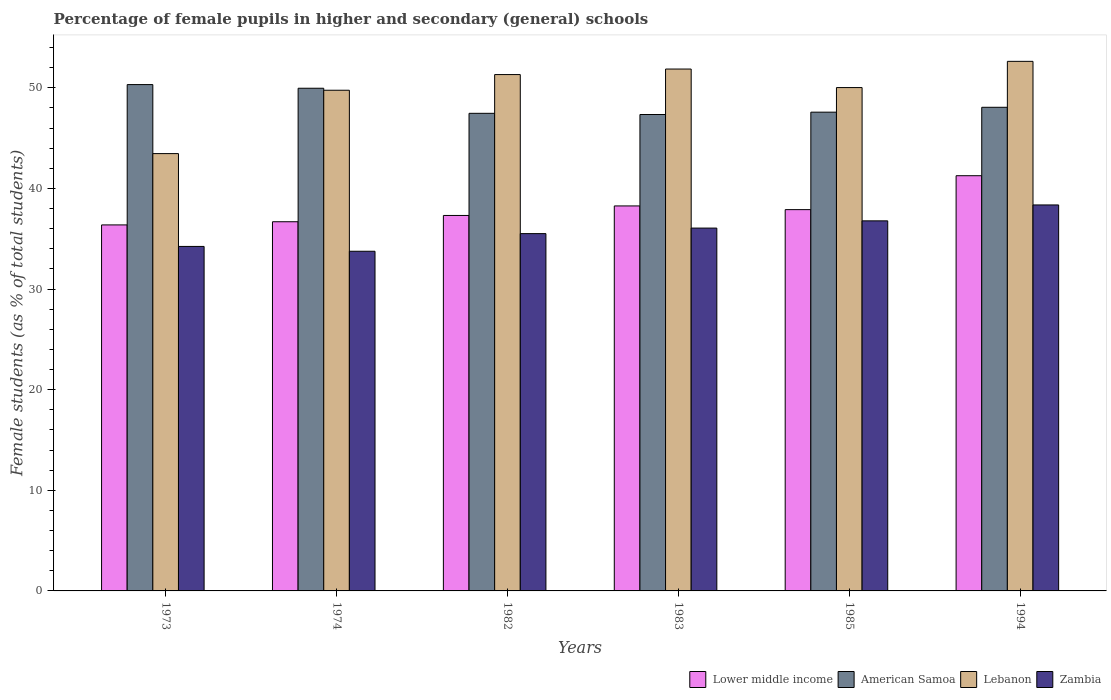How many different coloured bars are there?
Give a very brief answer. 4. Are the number of bars per tick equal to the number of legend labels?
Provide a succinct answer. Yes. Are the number of bars on each tick of the X-axis equal?
Offer a terse response. Yes. What is the label of the 2nd group of bars from the left?
Ensure brevity in your answer.  1974. In how many cases, is the number of bars for a given year not equal to the number of legend labels?
Offer a terse response. 0. What is the percentage of female pupils in higher and secondary schools in American Samoa in 1985?
Offer a terse response. 47.58. Across all years, what is the maximum percentage of female pupils in higher and secondary schools in American Samoa?
Your response must be concise. 50.32. Across all years, what is the minimum percentage of female pupils in higher and secondary schools in Zambia?
Offer a very short reply. 33.76. What is the total percentage of female pupils in higher and secondary schools in Zambia in the graph?
Offer a terse response. 214.71. What is the difference between the percentage of female pupils in higher and secondary schools in American Samoa in 1985 and that in 1994?
Make the answer very short. -0.48. What is the difference between the percentage of female pupils in higher and secondary schools in American Samoa in 1974 and the percentage of female pupils in higher and secondary schools in Zambia in 1985?
Provide a succinct answer. 13.18. What is the average percentage of female pupils in higher and secondary schools in American Samoa per year?
Ensure brevity in your answer.  48.46. In the year 1973, what is the difference between the percentage of female pupils in higher and secondary schools in Lebanon and percentage of female pupils in higher and secondary schools in Zambia?
Provide a succinct answer. 9.23. What is the ratio of the percentage of female pupils in higher and secondary schools in Lower middle income in 1982 to that in 1994?
Provide a succinct answer. 0.9. Is the difference between the percentage of female pupils in higher and secondary schools in Lebanon in 1974 and 1994 greater than the difference between the percentage of female pupils in higher and secondary schools in Zambia in 1974 and 1994?
Your response must be concise. Yes. What is the difference between the highest and the second highest percentage of female pupils in higher and secondary schools in Lower middle income?
Your answer should be compact. 3. What is the difference between the highest and the lowest percentage of female pupils in higher and secondary schools in Lower middle income?
Your answer should be very brief. 4.89. Is the sum of the percentage of female pupils in higher and secondary schools in Lower middle income in 1973 and 1983 greater than the maximum percentage of female pupils in higher and secondary schools in American Samoa across all years?
Provide a short and direct response. Yes. Is it the case that in every year, the sum of the percentage of female pupils in higher and secondary schools in Lebanon and percentage of female pupils in higher and secondary schools in Lower middle income is greater than the sum of percentage of female pupils in higher and secondary schools in Zambia and percentage of female pupils in higher and secondary schools in American Samoa?
Your response must be concise. Yes. What does the 3rd bar from the left in 1974 represents?
Your answer should be compact. Lebanon. What does the 1st bar from the right in 1973 represents?
Give a very brief answer. Zambia. How many bars are there?
Your response must be concise. 24. How many years are there in the graph?
Offer a very short reply. 6. Does the graph contain any zero values?
Your answer should be compact. No. Where does the legend appear in the graph?
Offer a terse response. Bottom right. What is the title of the graph?
Ensure brevity in your answer.  Percentage of female pupils in higher and secondary (general) schools. What is the label or title of the X-axis?
Provide a short and direct response. Years. What is the label or title of the Y-axis?
Provide a succinct answer. Female students (as % of total students). What is the Female students (as % of total students) in Lower middle income in 1973?
Provide a succinct answer. 36.38. What is the Female students (as % of total students) of American Samoa in 1973?
Your response must be concise. 50.32. What is the Female students (as % of total students) in Lebanon in 1973?
Give a very brief answer. 43.46. What is the Female students (as % of total students) of Zambia in 1973?
Make the answer very short. 34.24. What is the Female students (as % of total students) in Lower middle income in 1974?
Your answer should be very brief. 36.69. What is the Female students (as % of total students) in American Samoa in 1974?
Your response must be concise. 49.96. What is the Female students (as % of total students) in Lebanon in 1974?
Keep it short and to the point. 49.76. What is the Female students (as % of total students) in Zambia in 1974?
Make the answer very short. 33.76. What is the Female students (as % of total students) of Lower middle income in 1982?
Your answer should be very brief. 37.31. What is the Female students (as % of total students) of American Samoa in 1982?
Your answer should be very brief. 47.47. What is the Female students (as % of total students) of Lebanon in 1982?
Give a very brief answer. 51.32. What is the Female students (as % of total students) in Zambia in 1982?
Offer a terse response. 35.51. What is the Female students (as % of total students) of Lower middle income in 1983?
Give a very brief answer. 38.26. What is the Female students (as % of total students) in American Samoa in 1983?
Keep it short and to the point. 47.35. What is the Female students (as % of total students) in Lebanon in 1983?
Make the answer very short. 51.87. What is the Female students (as % of total students) in Zambia in 1983?
Your answer should be very brief. 36.06. What is the Female students (as % of total students) in Lower middle income in 1985?
Your answer should be very brief. 37.89. What is the Female students (as % of total students) of American Samoa in 1985?
Keep it short and to the point. 47.58. What is the Female students (as % of total students) of Lebanon in 1985?
Make the answer very short. 50.03. What is the Female students (as % of total students) of Zambia in 1985?
Your answer should be compact. 36.78. What is the Female students (as % of total students) of Lower middle income in 1994?
Offer a very short reply. 41.27. What is the Female students (as % of total students) in American Samoa in 1994?
Offer a terse response. 48.07. What is the Female students (as % of total students) of Lebanon in 1994?
Provide a succinct answer. 52.63. What is the Female students (as % of total students) of Zambia in 1994?
Make the answer very short. 38.36. Across all years, what is the maximum Female students (as % of total students) in Lower middle income?
Offer a very short reply. 41.27. Across all years, what is the maximum Female students (as % of total students) of American Samoa?
Provide a succinct answer. 50.32. Across all years, what is the maximum Female students (as % of total students) in Lebanon?
Offer a terse response. 52.63. Across all years, what is the maximum Female students (as % of total students) in Zambia?
Your answer should be compact. 38.36. Across all years, what is the minimum Female students (as % of total students) in Lower middle income?
Your answer should be very brief. 36.38. Across all years, what is the minimum Female students (as % of total students) of American Samoa?
Provide a short and direct response. 47.35. Across all years, what is the minimum Female students (as % of total students) of Lebanon?
Make the answer very short. 43.46. Across all years, what is the minimum Female students (as % of total students) of Zambia?
Your answer should be compact. 33.76. What is the total Female students (as % of total students) in Lower middle income in the graph?
Ensure brevity in your answer.  227.8. What is the total Female students (as % of total students) in American Samoa in the graph?
Ensure brevity in your answer.  290.74. What is the total Female students (as % of total students) in Lebanon in the graph?
Offer a terse response. 299.06. What is the total Female students (as % of total students) of Zambia in the graph?
Give a very brief answer. 214.71. What is the difference between the Female students (as % of total students) of Lower middle income in 1973 and that in 1974?
Offer a terse response. -0.31. What is the difference between the Female students (as % of total students) in American Samoa in 1973 and that in 1974?
Give a very brief answer. 0.36. What is the difference between the Female students (as % of total students) in Lebanon in 1973 and that in 1974?
Offer a terse response. -6.3. What is the difference between the Female students (as % of total students) of Zambia in 1973 and that in 1974?
Offer a very short reply. 0.48. What is the difference between the Female students (as % of total students) of Lower middle income in 1973 and that in 1982?
Your response must be concise. -0.94. What is the difference between the Female students (as % of total students) in American Samoa in 1973 and that in 1982?
Give a very brief answer. 2.86. What is the difference between the Female students (as % of total students) in Lebanon in 1973 and that in 1982?
Your answer should be very brief. -7.85. What is the difference between the Female students (as % of total students) of Zambia in 1973 and that in 1982?
Keep it short and to the point. -1.27. What is the difference between the Female students (as % of total students) of Lower middle income in 1973 and that in 1983?
Ensure brevity in your answer.  -1.89. What is the difference between the Female students (as % of total students) in American Samoa in 1973 and that in 1983?
Your answer should be compact. 2.97. What is the difference between the Female students (as % of total students) of Lebanon in 1973 and that in 1983?
Keep it short and to the point. -8.4. What is the difference between the Female students (as % of total students) in Zambia in 1973 and that in 1983?
Keep it short and to the point. -1.82. What is the difference between the Female students (as % of total students) in Lower middle income in 1973 and that in 1985?
Provide a succinct answer. -1.52. What is the difference between the Female students (as % of total students) in American Samoa in 1973 and that in 1985?
Make the answer very short. 2.74. What is the difference between the Female students (as % of total students) of Lebanon in 1973 and that in 1985?
Make the answer very short. -6.56. What is the difference between the Female students (as % of total students) in Zambia in 1973 and that in 1985?
Provide a succinct answer. -2.54. What is the difference between the Female students (as % of total students) of Lower middle income in 1973 and that in 1994?
Offer a terse response. -4.89. What is the difference between the Female students (as % of total students) in American Samoa in 1973 and that in 1994?
Keep it short and to the point. 2.26. What is the difference between the Female students (as % of total students) of Lebanon in 1973 and that in 1994?
Give a very brief answer. -9.17. What is the difference between the Female students (as % of total students) of Zambia in 1973 and that in 1994?
Provide a succinct answer. -4.12. What is the difference between the Female students (as % of total students) of Lower middle income in 1974 and that in 1982?
Make the answer very short. -0.62. What is the difference between the Female students (as % of total students) in American Samoa in 1974 and that in 1982?
Your answer should be compact. 2.49. What is the difference between the Female students (as % of total students) in Lebanon in 1974 and that in 1982?
Your response must be concise. -1.56. What is the difference between the Female students (as % of total students) of Zambia in 1974 and that in 1982?
Offer a terse response. -1.75. What is the difference between the Female students (as % of total students) in Lower middle income in 1974 and that in 1983?
Ensure brevity in your answer.  -1.57. What is the difference between the Female students (as % of total students) of American Samoa in 1974 and that in 1983?
Offer a terse response. 2.61. What is the difference between the Female students (as % of total students) of Lebanon in 1974 and that in 1983?
Give a very brief answer. -2.11. What is the difference between the Female students (as % of total students) in Zambia in 1974 and that in 1983?
Offer a very short reply. -2.3. What is the difference between the Female students (as % of total students) of Lower middle income in 1974 and that in 1985?
Your response must be concise. -1.2. What is the difference between the Female students (as % of total students) in American Samoa in 1974 and that in 1985?
Make the answer very short. 2.38. What is the difference between the Female students (as % of total students) in Lebanon in 1974 and that in 1985?
Ensure brevity in your answer.  -0.26. What is the difference between the Female students (as % of total students) of Zambia in 1974 and that in 1985?
Offer a terse response. -3.02. What is the difference between the Female students (as % of total students) in Lower middle income in 1974 and that in 1994?
Provide a short and direct response. -4.58. What is the difference between the Female students (as % of total students) of American Samoa in 1974 and that in 1994?
Make the answer very short. 1.89. What is the difference between the Female students (as % of total students) in Lebanon in 1974 and that in 1994?
Make the answer very short. -2.87. What is the difference between the Female students (as % of total students) in Zambia in 1974 and that in 1994?
Keep it short and to the point. -4.6. What is the difference between the Female students (as % of total students) of Lower middle income in 1982 and that in 1983?
Offer a terse response. -0.95. What is the difference between the Female students (as % of total students) of American Samoa in 1982 and that in 1983?
Provide a short and direct response. 0.12. What is the difference between the Female students (as % of total students) of Lebanon in 1982 and that in 1983?
Offer a terse response. -0.55. What is the difference between the Female students (as % of total students) of Zambia in 1982 and that in 1983?
Provide a short and direct response. -0.55. What is the difference between the Female students (as % of total students) of Lower middle income in 1982 and that in 1985?
Ensure brevity in your answer.  -0.58. What is the difference between the Female students (as % of total students) in American Samoa in 1982 and that in 1985?
Provide a succinct answer. -0.12. What is the difference between the Female students (as % of total students) of Lebanon in 1982 and that in 1985?
Provide a succinct answer. 1.29. What is the difference between the Female students (as % of total students) in Zambia in 1982 and that in 1985?
Make the answer very short. -1.27. What is the difference between the Female students (as % of total students) in Lower middle income in 1982 and that in 1994?
Offer a terse response. -3.95. What is the difference between the Female students (as % of total students) in American Samoa in 1982 and that in 1994?
Provide a succinct answer. -0.6. What is the difference between the Female students (as % of total students) in Lebanon in 1982 and that in 1994?
Offer a terse response. -1.31. What is the difference between the Female students (as % of total students) in Zambia in 1982 and that in 1994?
Your answer should be compact. -2.85. What is the difference between the Female students (as % of total students) of Lower middle income in 1983 and that in 1985?
Your response must be concise. 0.37. What is the difference between the Female students (as % of total students) of American Samoa in 1983 and that in 1985?
Give a very brief answer. -0.23. What is the difference between the Female students (as % of total students) in Lebanon in 1983 and that in 1985?
Your answer should be compact. 1.84. What is the difference between the Female students (as % of total students) of Zambia in 1983 and that in 1985?
Provide a short and direct response. -0.72. What is the difference between the Female students (as % of total students) of Lower middle income in 1983 and that in 1994?
Your answer should be very brief. -3. What is the difference between the Female students (as % of total students) in American Samoa in 1983 and that in 1994?
Provide a succinct answer. -0.72. What is the difference between the Female students (as % of total students) in Lebanon in 1983 and that in 1994?
Provide a succinct answer. -0.76. What is the difference between the Female students (as % of total students) in Zambia in 1983 and that in 1994?
Make the answer very short. -2.3. What is the difference between the Female students (as % of total students) of Lower middle income in 1985 and that in 1994?
Provide a succinct answer. -3.37. What is the difference between the Female students (as % of total students) in American Samoa in 1985 and that in 1994?
Make the answer very short. -0.48. What is the difference between the Female students (as % of total students) of Lebanon in 1985 and that in 1994?
Keep it short and to the point. -2.61. What is the difference between the Female students (as % of total students) of Zambia in 1985 and that in 1994?
Your answer should be very brief. -1.58. What is the difference between the Female students (as % of total students) in Lower middle income in 1973 and the Female students (as % of total students) in American Samoa in 1974?
Ensure brevity in your answer.  -13.58. What is the difference between the Female students (as % of total students) of Lower middle income in 1973 and the Female students (as % of total students) of Lebanon in 1974?
Give a very brief answer. -13.38. What is the difference between the Female students (as % of total students) in Lower middle income in 1973 and the Female students (as % of total students) in Zambia in 1974?
Offer a very short reply. 2.62. What is the difference between the Female students (as % of total students) of American Samoa in 1973 and the Female students (as % of total students) of Lebanon in 1974?
Offer a very short reply. 0.56. What is the difference between the Female students (as % of total students) of American Samoa in 1973 and the Female students (as % of total students) of Zambia in 1974?
Make the answer very short. 16.57. What is the difference between the Female students (as % of total students) in Lebanon in 1973 and the Female students (as % of total students) in Zambia in 1974?
Offer a very short reply. 9.71. What is the difference between the Female students (as % of total students) in Lower middle income in 1973 and the Female students (as % of total students) in American Samoa in 1982?
Your response must be concise. -11.09. What is the difference between the Female students (as % of total students) of Lower middle income in 1973 and the Female students (as % of total students) of Lebanon in 1982?
Your response must be concise. -14.94. What is the difference between the Female students (as % of total students) of Lower middle income in 1973 and the Female students (as % of total students) of Zambia in 1982?
Keep it short and to the point. 0.86. What is the difference between the Female students (as % of total students) of American Samoa in 1973 and the Female students (as % of total students) of Lebanon in 1982?
Ensure brevity in your answer.  -1. What is the difference between the Female students (as % of total students) of American Samoa in 1973 and the Female students (as % of total students) of Zambia in 1982?
Your answer should be very brief. 14.81. What is the difference between the Female students (as % of total students) of Lebanon in 1973 and the Female students (as % of total students) of Zambia in 1982?
Your response must be concise. 7.95. What is the difference between the Female students (as % of total students) of Lower middle income in 1973 and the Female students (as % of total students) of American Samoa in 1983?
Your answer should be compact. -10.97. What is the difference between the Female students (as % of total students) in Lower middle income in 1973 and the Female students (as % of total students) in Lebanon in 1983?
Ensure brevity in your answer.  -15.49. What is the difference between the Female students (as % of total students) of Lower middle income in 1973 and the Female students (as % of total students) of Zambia in 1983?
Ensure brevity in your answer.  0.32. What is the difference between the Female students (as % of total students) in American Samoa in 1973 and the Female students (as % of total students) in Lebanon in 1983?
Provide a short and direct response. -1.55. What is the difference between the Female students (as % of total students) in American Samoa in 1973 and the Female students (as % of total students) in Zambia in 1983?
Offer a terse response. 14.26. What is the difference between the Female students (as % of total students) of Lebanon in 1973 and the Female students (as % of total students) of Zambia in 1983?
Keep it short and to the point. 7.4. What is the difference between the Female students (as % of total students) of Lower middle income in 1973 and the Female students (as % of total students) of American Samoa in 1985?
Your response must be concise. -11.21. What is the difference between the Female students (as % of total students) in Lower middle income in 1973 and the Female students (as % of total students) in Lebanon in 1985?
Your response must be concise. -13.65. What is the difference between the Female students (as % of total students) of Lower middle income in 1973 and the Female students (as % of total students) of Zambia in 1985?
Make the answer very short. -0.4. What is the difference between the Female students (as % of total students) of American Samoa in 1973 and the Female students (as % of total students) of Lebanon in 1985?
Give a very brief answer. 0.3. What is the difference between the Female students (as % of total students) in American Samoa in 1973 and the Female students (as % of total students) in Zambia in 1985?
Your response must be concise. 13.54. What is the difference between the Female students (as % of total students) in Lebanon in 1973 and the Female students (as % of total students) in Zambia in 1985?
Give a very brief answer. 6.68. What is the difference between the Female students (as % of total students) in Lower middle income in 1973 and the Female students (as % of total students) in American Samoa in 1994?
Your answer should be compact. -11.69. What is the difference between the Female students (as % of total students) of Lower middle income in 1973 and the Female students (as % of total students) of Lebanon in 1994?
Ensure brevity in your answer.  -16.25. What is the difference between the Female students (as % of total students) of Lower middle income in 1973 and the Female students (as % of total students) of Zambia in 1994?
Keep it short and to the point. -1.98. What is the difference between the Female students (as % of total students) in American Samoa in 1973 and the Female students (as % of total students) in Lebanon in 1994?
Your response must be concise. -2.31. What is the difference between the Female students (as % of total students) of American Samoa in 1973 and the Female students (as % of total students) of Zambia in 1994?
Keep it short and to the point. 11.96. What is the difference between the Female students (as % of total students) in Lebanon in 1973 and the Female students (as % of total students) in Zambia in 1994?
Your answer should be compact. 5.1. What is the difference between the Female students (as % of total students) of Lower middle income in 1974 and the Female students (as % of total students) of American Samoa in 1982?
Offer a terse response. -10.78. What is the difference between the Female students (as % of total students) in Lower middle income in 1974 and the Female students (as % of total students) in Lebanon in 1982?
Offer a very short reply. -14.63. What is the difference between the Female students (as % of total students) in Lower middle income in 1974 and the Female students (as % of total students) in Zambia in 1982?
Ensure brevity in your answer.  1.18. What is the difference between the Female students (as % of total students) of American Samoa in 1974 and the Female students (as % of total students) of Lebanon in 1982?
Your answer should be compact. -1.36. What is the difference between the Female students (as % of total students) of American Samoa in 1974 and the Female students (as % of total students) of Zambia in 1982?
Keep it short and to the point. 14.45. What is the difference between the Female students (as % of total students) of Lebanon in 1974 and the Female students (as % of total students) of Zambia in 1982?
Your answer should be very brief. 14.25. What is the difference between the Female students (as % of total students) in Lower middle income in 1974 and the Female students (as % of total students) in American Samoa in 1983?
Provide a short and direct response. -10.66. What is the difference between the Female students (as % of total students) of Lower middle income in 1974 and the Female students (as % of total students) of Lebanon in 1983?
Provide a short and direct response. -15.18. What is the difference between the Female students (as % of total students) in Lower middle income in 1974 and the Female students (as % of total students) in Zambia in 1983?
Ensure brevity in your answer.  0.63. What is the difference between the Female students (as % of total students) in American Samoa in 1974 and the Female students (as % of total students) in Lebanon in 1983?
Your answer should be compact. -1.91. What is the difference between the Female students (as % of total students) in American Samoa in 1974 and the Female students (as % of total students) in Zambia in 1983?
Give a very brief answer. 13.9. What is the difference between the Female students (as % of total students) of Lebanon in 1974 and the Female students (as % of total students) of Zambia in 1983?
Offer a very short reply. 13.7. What is the difference between the Female students (as % of total students) of Lower middle income in 1974 and the Female students (as % of total students) of American Samoa in 1985?
Offer a terse response. -10.89. What is the difference between the Female students (as % of total students) in Lower middle income in 1974 and the Female students (as % of total students) in Lebanon in 1985?
Keep it short and to the point. -13.33. What is the difference between the Female students (as % of total students) in Lower middle income in 1974 and the Female students (as % of total students) in Zambia in 1985?
Provide a succinct answer. -0.09. What is the difference between the Female students (as % of total students) of American Samoa in 1974 and the Female students (as % of total students) of Lebanon in 1985?
Make the answer very short. -0.07. What is the difference between the Female students (as % of total students) in American Samoa in 1974 and the Female students (as % of total students) in Zambia in 1985?
Provide a succinct answer. 13.18. What is the difference between the Female students (as % of total students) in Lebanon in 1974 and the Female students (as % of total students) in Zambia in 1985?
Your answer should be very brief. 12.98. What is the difference between the Female students (as % of total students) in Lower middle income in 1974 and the Female students (as % of total students) in American Samoa in 1994?
Provide a short and direct response. -11.38. What is the difference between the Female students (as % of total students) in Lower middle income in 1974 and the Female students (as % of total students) in Lebanon in 1994?
Your answer should be compact. -15.94. What is the difference between the Female students (as % of total students) in Lower middle income in 1974 and the Female students (as % of total students) in Zambia in 1994?
Provide a short and direct response. -1.67. What is the difference between the Female students (as % of total students) of American Samoa in 1974 and the Female students (as % of total students) of Lebanon in 1994?
Provide a short and direct response. -2.67. What is the difference between the Female students (as % of total students) in American Samoa in 1974 and the Female students (as % of total students) in Zambia in 1994?
Provide a short and direct response. 11.6. What is the difference between the Female students (as % of total students) of Lebanon in 1974 and the Female students (as % of total students) of Zambia in 1994?
Give a very brief answer. 11.4. What is the difference between the Female students (as % of total students) of Lower middle income in 1982 and the Female students (as % of total students) of American Samoa in 1983?
Your answer should be very brief. -10.03. What is the difference between the Female students (as % of total students) of Lower middle income in 1982 and the Female students (as % of total students) of Lebanon in 1983?
Your response must be concise. -14.55. What is the difference between the Female students (as % of total students) in Lower middle income in 1982 and the Female students (as % of total students) in Zambia in 1983?
Offer a very short reply. 1.25. What is the difference between the Female students (as % of total students) of American Samoa in 1982 and the Female students (as % of total students) of Lebanon in 1983?
Your answer should be compact. -4.4. What is the difference between the Female students (as % of total students) in American Samoa in 1982 and the Female students (as % of total students) in Zambia in 1983?
Provide a succinct answer. 11.41. What is the difference between the Female students (as % of total students) in Lebanon in 1982 and the Female students (as % of total students) in Zambia in 1983?
Offer a terse response. 15.26. What is the difference between the Female students (as % of total students) in Lower middle income in 1982 and the Female students (as % of total students) in American Samoa in 1985?
Your answer should be compact. -10.27. What is the difference between the Female students (as % of total students) in Lower middle income in 1982 and the Female students (as % of total students) in Lebanon in 1985?
Offer a terse response. -12.71. What is the difference between the Female students (as % of total students) of Lower middle income in 1982 and the Female students (as % of total students) of Zambia in 1985?
Your answer should be very brief. 0.54. What is the difference between the Female students (as % of total students) of American Samoa in 1982 and the Female students (as % of total students) of Lebanon in 1985?
Keep it short and to the point. -2.56. What is the difference between the Female students (as % of total students) of American Samoa in 1982 and the Female students (as % of total students) of Zambia in 1985?
Make the answer very short. 10.69. What is the difference between the Female students (as % of total students) of Lebanon in 1982 and the Female students (as % of total students) of Zambia in 1985?
Provide a succinct answer. 14.54. What is the difference between the Female students (as % of total students) in Lower middle income in 1982 and the Female students (as % of total students) in American Samoa in 1994?
Offer a terse response. -10.75. What is the difference between the Female students (as % of total students) in Lower middle income in 1982 and the Female students (as % of total students) in Lebanon in 1994?
Give a very brief answer. -15.32. What is the difference between the Female students (as % of total students) in Lower middle income in 1982 and the Female students (as % of total students) in Zambia in 1994?
Offer a very short reply. -1.05. What is the difference between the Female students (as % of total students) of American Samoa in 1982 and the Female students (as % of total students) of Lebanon in 1994?
Ensure brevity in your answer.  -5.17. What is the difference between the Female students (as % of total students) of American Samoa in 1982 and the Female students (as % of total students) of Zambia in 1994?
Make the answer very short. 9.11. What is the difference between the Female students (as % of total students) in Lebanon in 1982 and the Female students (as % of total students) in Zambia in 1994?
Keep it short and to the point. 12.96. What is the difference between the Female students (as % of total students) in Lower middle income in 1983 and the Female students (as % of total students) in American Samoa in 1985?
Provide a short and direct response. -9.32. What is the difference between the Female students (as % of total students) in Lower middle income in 1983 and the Female students (as % of total students) in Lebanon in 1985?
Your answer should be compact. -11.76. What is the difference between the Female students (as % of total students) in Lower middle income in 1983 and the Female students (as % of total students) in Zambia in 1985?
Give a very brief answer. 1.48. What is the difference between the Female students (as % of total students) in American Samoa in 1983 and the Female students (as % of total students) in Lebanon in 1985?
Make the answer very short. -2.68. What is the difference between the Female students (as % of total students) of American Samoa in 1983 and the Female students (as % of total students) of Zambia in 1985?
Give a very brief answer. 10.57. What is the difference between the Female students (as % of total students) in Lebanon in 1983 and the Female students (as % of total students) in Zambia in 1985?
Give a very brief answer. 15.09. What is the difference between the Female students (as % of total students) of Lower middle income in 1983 and the Female students (as % of total students) of American Samoa in 1994?
Provide a succinct answer. -9.8. What is the difference between the Female students (as % of total students) of Lower middle income in 1983 and the Female students (as % of total students) of Lebanon in 1994?
Ensure brevity in your answer.  -14.37. What is the difference between the Female students (as % of total students) in Lower middle income in 1983 and the Female students (as % of total students) in Zambia in 1994?
Make the answer very short. -0.1. What is the difference between the Female students (as % of total students) of American Samoa in 1983 and the Female students (as % of total students) of Lebanon in 1994?
Your answer should be very brief. -5.28. What is the difference between the Female students (as % of total students) of American Samoa in 1983 and the Female students (as % of total students) of Zambia in 1994?
Keep it short and to the point. 8.99. What is the difference between the Female students (as % of total students) in Lebanon in 1983 and the Female students (as % of total students) in Zambia in 1994?
Provide a succinct answer. 13.51. What is the difference between the Female students (as % of total students) in Lower middle income in 1985 and the Female students (as % of total students) in American Samoa in 1994?
Offer a very short reply. -10.17. What is the difference between the Female students (as % of total students) in Lower middle income in 1985 and the Female students (as % of total students) in Lebanon in 1994?
Make the answer very short. -14.74. What is the difference between the Female students (as % of total students) in Lower middle income in 1985 and the Female students (as % of total students) in Zambia in 1994?
Give a very brief answer. -0.47. What is the difference between the Female students (as % of total students) of American Samoa in 1985 and the Female students (as % of total students) of Lebanon in 1994?
Ensure brevity in your answer.  -5.05. What is the difference between the Female students (as % of total students) in American Samoa in 1985 and the Female students (as % of total students) in Zambia in 1994?
Your answer should be very brief. 9.22. What is the difference between the Female students (as % of total students) of Lebanon in 1985 and the Female students (as % of total students) of Zambia in 1994?
Your answer should be compact. 11.66. What is the average Female students (as % of total students) of Lower middle income per year?
Provide a short and direct response. 37.97. What is the average Female students (as % of total students) in American Samoa per year?
Your response must be concise. 48.46. What is the average Female students (as % of total students) of Lebanon per year?
Make the answer very short. 49.84. What is the average Female students (as % of total students) of Zambia per year?
Ensure brevity in your answer.  35.78. In the year 1973, what is the difference between the Female students (as % of total students) in Lower middle income and Female students (as % of total students) in American Samoa?
Give a very brief answer. -13.95. In the year 1973, what is the difference between the Female students (as % of total students) of Lower middle income and Female students (as % of total students) of Lebanon?
Provide a succinct answer. -7.09. In the year 1973, what is the difference between the Female students (as % of total students) of Lower middle income and Female students (as % of total students) of Zambia?
Your response must be concise. 2.14. In the year 1973, what is the difference between the Female students (as % of total students) in American Samoa and Female students (as % of total students) in Lebanon?
Offer a terse response. 6.86. In the year 1973, what is the difference between the Female students (as % of total students) of American Samoa and Female students (as % of total students) of Zambia?
Offer a terse response. 16.08. In the year 1973, what is the difference between the Female students (as % of total students) of Lebanon and Female students (as % of total students) of Zambia?
Ensure brevity in your answer.  9.23. In the year 1974, what is the difference between the Female students (as % of total students) of Lower middle income and Female students (as % of total students) of American Samoa?
Your answer should be very brief. -13.27. In the year 1974, what is the difference between the Female students (as % of total students) in Lower middle income and Female students (as % of total students) in Lebanon?
Provide a succinct answer. -13.07. In the year 1974, what is the difference between the Female students (as % of total students) of Lower middle income and Female students (as % of total students) of Zambia?
Provide a succinct answer. 2.93. In the year 1974, what is the difference between the Female students (as % of total students) of American Samoa and Female students (as % of total students) of Lebanon?
Provide a succinct answer. 0.2. In the year 1974, what is the difference between the Female students (as % of total students) in American Samoa and Female students (as % of total students) in Zambia?
Provide a succinct answer. 16.2. In the year 1974, what is the difference between the Female students (as % of total students) of Lebanon and Female students (as % of total students) of Zambia?
Give a very brief answer. 16. In the year 1982, what is the difference between the Female students (as % of total students) of Lower middle income and Female students (as % of total students) of American Samoa?
Provide a succinct answer. -10.15. In the year 1982, what is the difference between the Female students (as % of total students) in Lower middle income and Female students (as % of total students) in Lebanon?
Keep it short and to the point. -14. In the year 1982, what is the difference between the Female students (as % of total students) of Lower middle income and Female students (as % of total students) of Zambia?
Your answer should be very brief. 1.8. In the year 1982, what is the difference between the Female students (as % of total students) in American Samoa and Female students (as % of total students) in Lebanon?
Your response must be concise. -3.85. In the year 1982, what is the difference between the Female students (as % of total students) in American Samoa and Female students (as % of total students) in Zambia?
Provide a succinct answer. 11.95. In the year 1982, what is the difference between the Female students (as % of total students) in Lebanon and Female students (as % of total students) in Zambia?
Keep it short and to the point. 15.81. In the year 1983, what is the difference between the Female students (as % of total students) of Lower middle income and Female students (as % of total students) of American Samoa?
Make the answer very short. -9.09. In the year 1983, what is the difference between the Female students (as % of total students) of Lower middle income and Female students (as % of total students) of Lebanon?
Make the answer very short. -13.61. In the year 1983, what is the difference between the Female students (as % of total students) in Lower middle income and Female students (as % of total students) in Zambia?
Offer a terse response. 2.2. In the year 1983, what is the difference between the Female students (as % of total students) of American Samoa and Female students (as % of total students) of Lebanon?
Your answer should be compact. -4.52. In the year 1983, what is the difference between the Female students (as % of total students) in American Samoa and Female students (as % of total students) in Zambia?
Ensure brevity in your answer.  11.29. In the year 1983, what is the difference between the Female students (as % of total students) in Lebanon and Female students (as % of total students) in Zambia?
Your response must be concise. 15.81. In the year 1985, what is the difference between the Female students (as % of total students) in Lower middle income and Female students (as % of total students) in American Samoa?
Make the answer very short. -9.69. In the year 1985, what is the difference between the Female students (as % of total students) of Lower middle income and Female students (as % of total students) of Lebanon?
Provide a short and direct response. -12.13. In the year 1985, what is the difference between the Female students (as % of total students) in Lower middle income and Female students (as % of total students) in Zambia?
Your response must be concise. 1.11. In the year 1985, what is the difference between the Female students (as % of total students) in American Samoa and Female students (as % of total students) in Lebanon?
Ensure brevity in your answer.  -2.44. In the year 1985, what is the difference between the Female students (as % of total students) in American Samoa and Female students (as % of total students) in Zambia?
Make the answer very short. 10.8. In the year 1985, what is the difference between the Female students (as % of total students) of Lebanon and Female students (as % of total students) of Zambia?
Give a very brief answer. 13.25. In the year 1994, what is the difference between the Female students (as % of total students) of Lower middle income and Female students (as % of total students) of American Samoa?
Your answer should be very brief. -6.8. In the year 1994, what is the difference between the Female students (as % of total students) of Lower middle income and Female students (as % of total students) of Lebanon?
Your response must be concise. -11.37. In the year 1994, what is the difference between the Female students (as % of total students) in Lower middle income and Female students (as % of total students) in Zambia?
Make the answer very short. 2.9. In the year 1994, what is the difference between the Female students (as % of total students) in American Samoa and Female students (as % of total students) in Lebanon?
Give a very brief answer. -4.56. In the year 1994, what is the difference between the Female students (as % of total students) in American Samoa and Female students (as % of total students) in Zambia?
Ensure brevity in your answer.  9.71. In the year 1994, what is the difference between the Female students (as % of total students) in Lebanon and Female students (as % of total students) in Zambia?
Ensure brevity in your answer.  14.27. What is the ratio of the Female students (as % of total students) in Lower middle income in 1973 to that in 1974?
Provide a succinct answer. 0.99. What is the ratio of the Female students (as % of total students) in American Samoa in 1973 to that in 1974?
Offer a very short reply. 1.01. What is the ratio of the Female students (as % of total students) in Lebanon in 1973 to that in 1974?
Make the answer very short. 0.87. What is the ratio of the Female students (as % of total students) of Zambia in 1973 to that in 1974?
Keep it short and to the point. 1.01. What is the ratio of the Female students (as % of total students) in Lower middle income in 1973 to that in 1982?
Ensure brevity in your answer.  0.97. What is the ratio of the Female students (as % of total students) in American Samoa in 1973 to that in 1982?
Your answer should be very brief. 1.06. What is the ratio of the Female students (as % of total students) of Lebanon in 1973 to that in 1982?
Your response must be concise. 0.85. What is the ratio of the Female students (as % of total students) of Zambia in 1973 to that in 1982?
Provide a succinct answer. 0.96. What is the ratio of the Female students (as % of total students) of Lower middle income in 1973 to that in 1983?
Keep it short and to the point. 0.95. What is the ratio of the Female students (as % of total students) in American Samoa in 1973 to that in 1983?
Make the answer very short. 1.06. What is the ratio of the Female students (as % of total students) of Lebanon in 1973 to that in 1983?
Provide a short and direct response. 0.84. What is the ratio of the Female students (as % of total students) in Zambia in 1973 to that in 1983?
Your answer should be compact. 0.95. What is the ratio of the Female students (as % of total students) of Lower middle income in 1973 to that in 1985?
Your answer should be very brief. 0.96. What is the ratio of the Female students (as % of total students) of American Samoa in 1973 to that in 1985?
Make the answer very short. 1.06. What is the ratio of the Female students (as % of total students) of Lebanon in 1973 to that in 1985?
Your answer should be very brief. 0.87. What is the ratio of the Female students (as % of total students) of Zambia in 1973 to that in 1985?
Keep it short and to the point. 0.93. What is the ratio of the Female students (as % of total students) in Lower middle income in 1973 to that in 1994?
Offer a terse response. 0.88. What is the ratio of the Female students (as % of total students) of American Samoa in 1973 to that in 1994?
Provide a short and direct response. 1.05. What is the ratio of the Female students (as % of total students) in Lebanon in 1973 to that in 1994?
Your answer should be compact. 0.83. What is the ratio of the Female students (as % of total students) in Zambia in 1973 to that in 1994?
Offer a terse response. 0.89. What is the ratio of the Female students (as % of total students) of Lower middle income in 1974 to that in 1982?
Offer a very short reply. 0.98. What is the ratio of the Female students (as % of total students) of American Samoa in 1974 to that in 1982?
Offer a very short reply. 1.05. What is the ratio of the Female students (as % of total students) in Lebanon in 1974 to that in 1982?
Keep it short and to the point. 0.97. What is the ratio of the Female students (as % of total students) in Zambia in 1974 to that in 1982?
Offer a terse response. 0.95. What is the ratio of the Female students (as % of total students) in Lower middle income in 1974 to that in 1983?
Your response must be concise. 0.96. What is the ratio of the Female students (as % of total students) in American Samoa in 1974 to that in 1983?
Offer a terse response. 1.06. What is the ratio of the Female students (as % of total students) in Lebanon in 1974 to that in 1983?
Provide a short and direct response. 0.96. What is the ratio of the Female students (as % of total students) in Zambia in 1974 to that in 1983?
Your answer should be compact. 0.94. What is the ratio of the Female students (as % of total students) in Lower middle income in 1974 to that in 1985?
Make the answer very short. 0.97. What is the ratio of the Female students (as % of total students) of Zambia in 1974 to that in 1985?
Offer a terse response. 0.92. What is the ratio of the Female students (as % of total students) of Lower middle income in 1974 to that in 1994?
Make the answer very short. 0.89. What is the ratio of the Female students (as % of total students) of American Samoa in 1974 to that in 1994?
Ensure brevity in your answer.  1.04. What is the ratio of the Female students (as % of total students) of Lebanon in 1974 to that in 1994?
Your response must be concise. 0.95. What is the ratio of the Female students (as % of total students) in Zambia in 1974 to that in 1994?
Make the answer very short. 0.88. What is the ratio of the Female students (as % of total students) in Lower middle income in 1982 to that in 1983?
Your answer should be very brief. 0.98. What is the ratio of the Female students (as % of total students) in Lebanon in 1982 to that in 1983?
Offer a very short reply. 0.99. What is the ratio of the Female students (as % of total students) of Zambia in 1982 to that in 1983?
Your response must be concise. 0.98. What is the ratio of the Female students (as % of total students) of Lower middle income in 1982 to that in 1985?
Your answer should be very brief. 0.98. What is the ratio of the Female students (as % of total students) of American Samoa in 1982 to that in 1985?
Your answer should be very brief. 1. What is the ratio of the Female students (as % of total students) in Lebanon in 1982 to that in 1985?
Offer a very short reply. 1.03. What is the ratio of the Female students (as % of total students) in Zambia in 1982 to that in 1985?
Make the answer very short. 0.97. What is the ratio of the Female students (as % of total students) of Lower middle income in 1982 to that in 1994?
Provide a succinct answer. 0.9. What is the ratio of the Female students (as % of total students) in American Samoa in 1982 to that in 1994?
Provide a succinct answer. 0.99. What is the ratio of the Female students (as % of total students) of Lebanon in 1982 to that in 1994?
Offer a terse response. 0.97. What is the ratio of the Female students (as % of total students) of Zambia in 1982 to that in 1994?
Give a very brief answer. 0.93. What is the ratio of the Female students (as % of total students) in Lower middle income in 1983 to that in 1985?
Your response must be concise. 1.01. What is the ratio of the Female students (as % of total students) of American Samoa in 1983 to that in 1985?
Offer a terse response. 1. What is the ratio of the Female students (as % of total students) of Lebanon in 1983 to that in 1985?
Your answer should be compact. 1.04. What is the ratio of the Female students (as % of total students) of Zambia in 1983 to that in 1985?
Provide a short and direct response. 0.98. What is the ratio of the Female students (as % of total students) of Lower middle income in 1983 to that in 1994?
Keep it short and to the point. 0.93. What is the ratio of the Female students (as % of total students) of American Samoa in 1983 to that in 1994?
Your answer should be very brief. 0.99. What is the ratio of the Female students (as % of total students) in Lebanon in 1983 to that in 1994?
Give a very brief answer. 0.99. What is the ratio of the Female students (as % of total students) in Zambia in 1983 to that in 1994?
Make the answer very short. 0.94. What is the ratio of the Female students (as % of total students) in Lower middle income in 1985 to that in 1994?
Keep it short and to the point. 0.92. What is the ratio of the Female students (as % of total students) of American Samoa in 1985 to that in 1994?
Make the answer very short. 0.99. What is the ratio of the Female students (as % of total students) in Lebanon in 1985 to that in 1994?
Keep it short and to the point. 0.95. What is the ratio of the Female students (as % of total students) in Zambia in 1985 to that in 1994?
Your response must be concise. 0.96. What is the difference between the highest and the second highest Female students (as % of total students) of Lower middle income?
Your answer should be compact. 3. What is the difference between the highest and the second highest Female students (as % of total students) in American Samoa?
Ensure brevity in your answer.  0.36. What is the difference between the highest and the second highest Female students (as % of total students) of Lebanon?
Offer a terse response. 0.76. What is the difference between the highest and the second highest Female students (as % of total students) of Zambia?
Offer a terse response. 1.58. What is the difference between the highest and the lowest Female students (as % of total students) in Lower middle income?
Offer a very short reply. 4.89. What is the difference between the highest and the lowest Female students (as % of total students) of American Samoa?
Give a very brief answer. 2.97. What is the difference between the highest and the lowest Female students (as % of total students) in Lebanon?
Keep it short and to the point. 9.17. What is the difference between the highest and the lowest Female students (as % of total students) in Zambia?
Give a very brief answer. 4.6. 